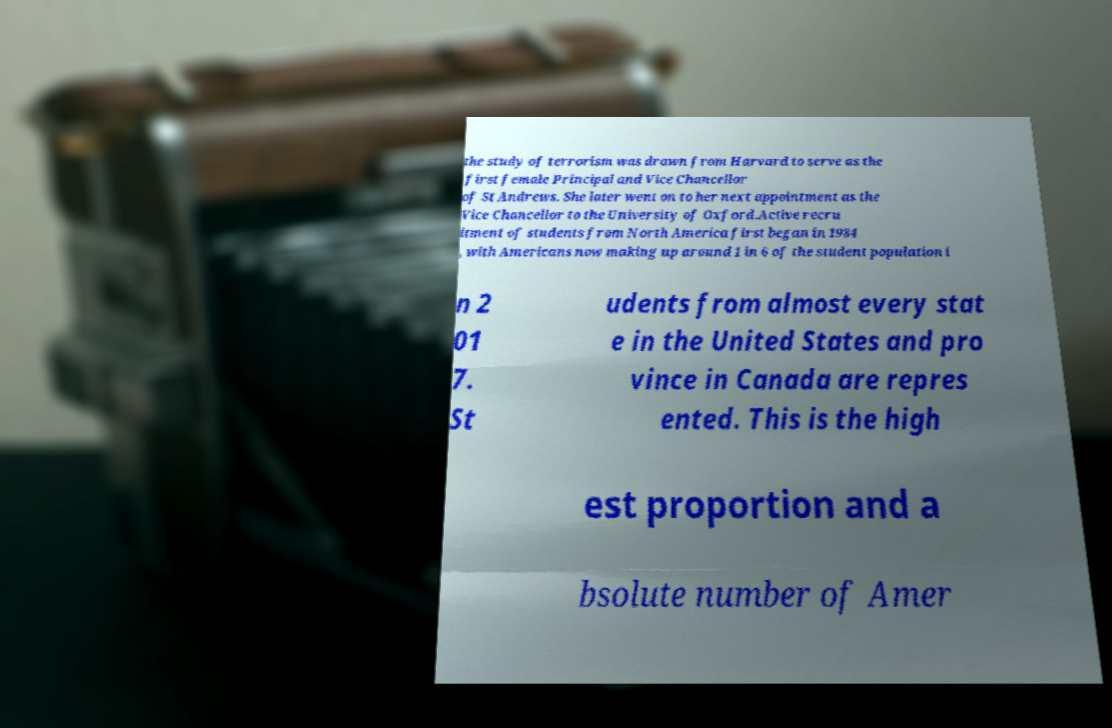Can you read and provide the text displayed in the image?This photo seems to have some interesting text. Can you extract and type it out for me? the study of terrorism was drawn from Harvard to serve as the first female Principal and Vice Chancellor of St Andrews. She later went on to her next appointment as the Vice Chancellor to the University of Oxford.Active recru itment of students from North America first began in 1984 , with Americans now making up around 1 in 6 of the student population i n 2 01 7. St udents from almost every stat e in the United States and pro vince in Canada are repres ented. This is the high est proportion and a bsolute number of Amer 